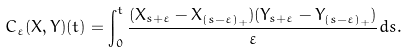<formula> <loc_0><loc_0><loc_500><loc_500>C _ { \varepsilon } ( X , Y ) ( t ) = \int _ { 0 } ^ { t } \frac { ( X _ { s + \varepsilon } - X _ { ( s - \varepsilon ) _ { + } } ) ( Y _ { s + \varepsilon } - Y _ { ( s - \varepsilon ) _ { + } } ) } { \varepsilon } d s .</formula> 